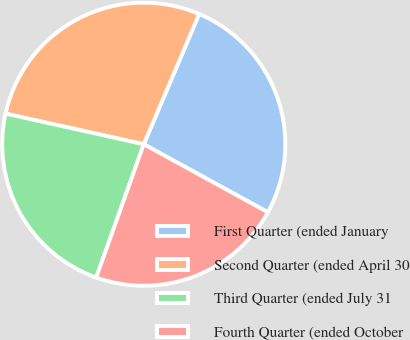Convert chart. <chart><loc_0><loc_0><loc_500><loc_500><pie_chart><fcel>First Quarter (ended January<fcel>Second Quarter (ended April 30<fcel>Third Quarter (ended July 31<fcel>Fourth Quarter (ended October<nl><fcel>26.58%<fcel>27.93%<fcel>23.02%<fcel>22.47%<nl></chart> 